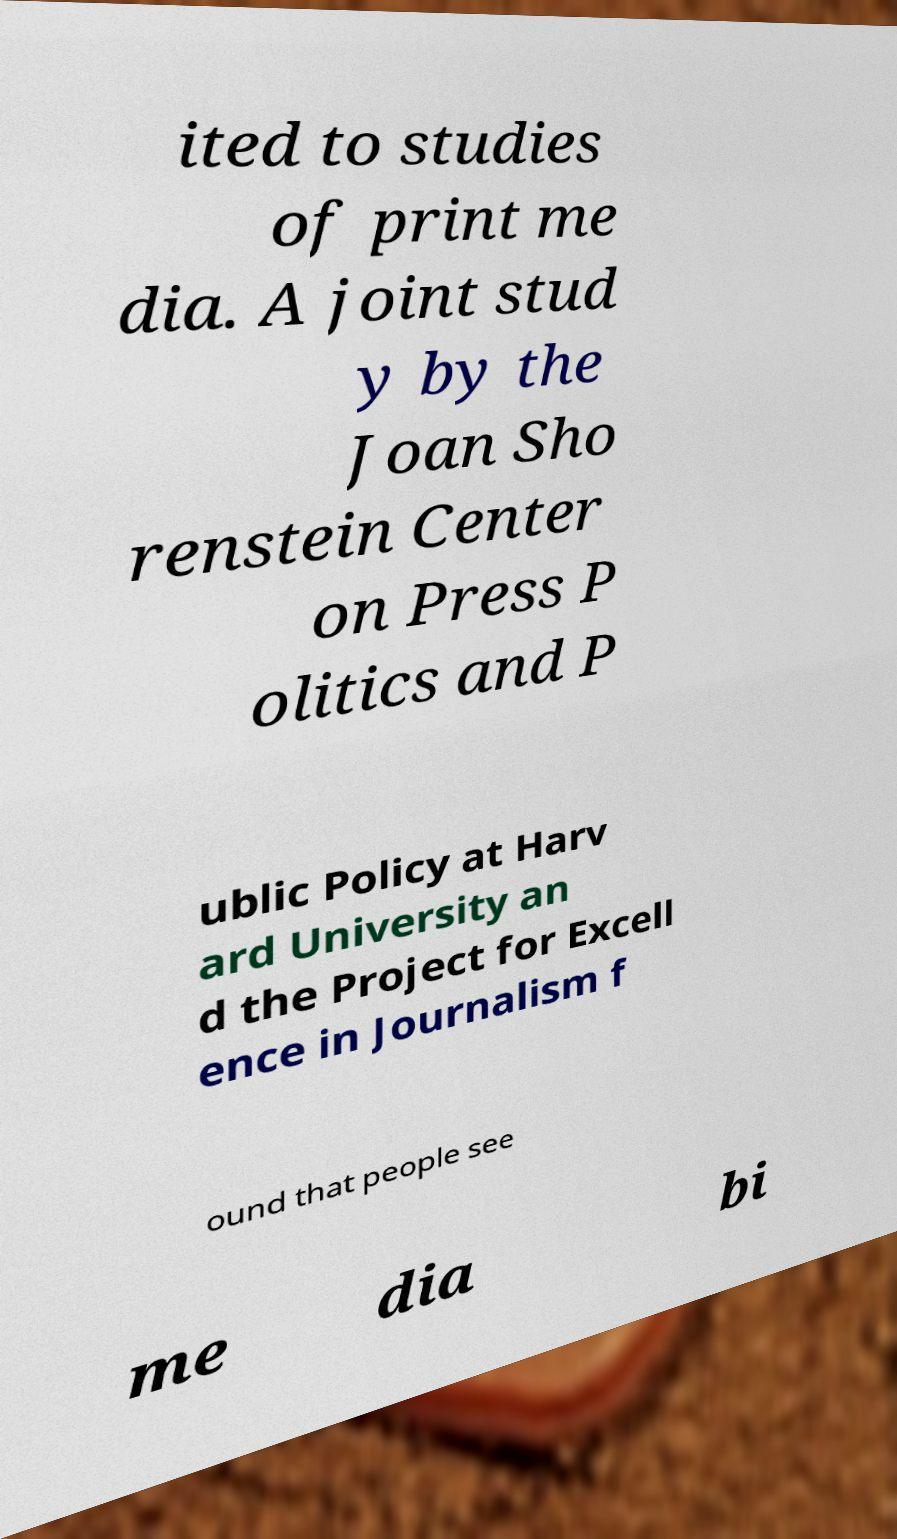For documentation purposes, I need the text within this image transcribed. Could you provide that? ited to studies of print me dia. A joint stud y by the Joan Sho renstein Center on Press P olitics and P ublic Policy at Harv ard University an d the Project for Excell ence in Journalism f ound that people see me dia bi 